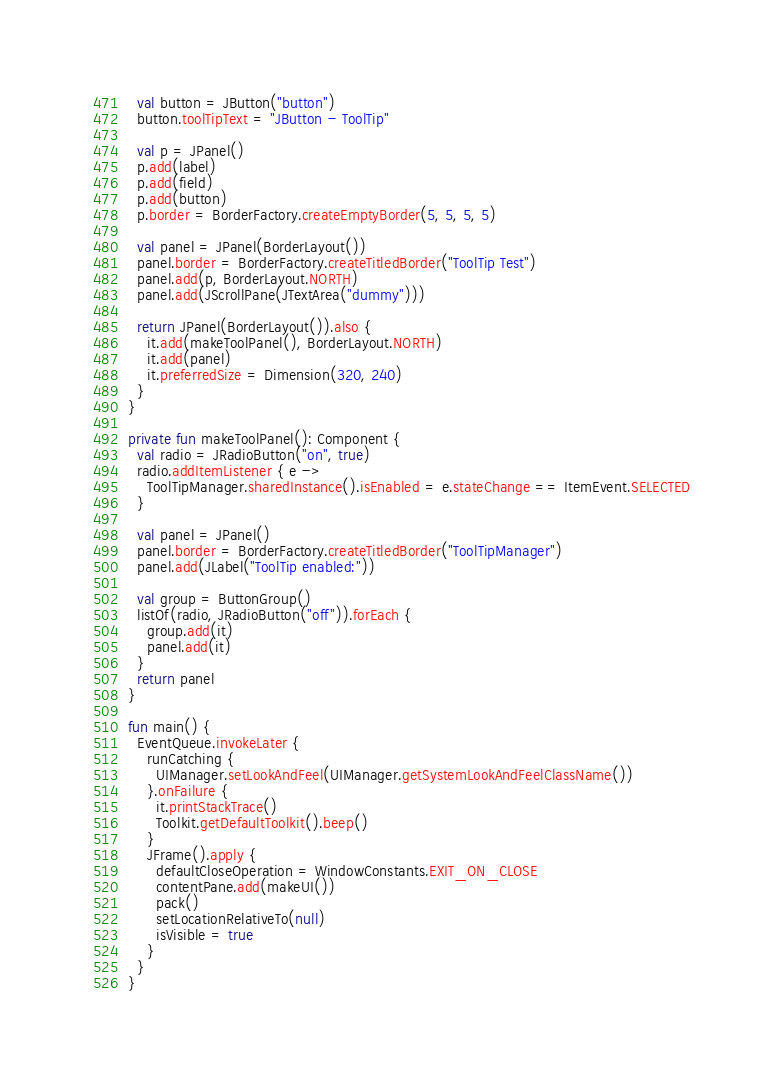<code> <loc_0><loc_0><loc_500><loc_500><_Kotlin_>  val button = JButton("button")
  button.toolTipText = "JButton - ToolTip"

  val p = JPanel()
  p.add(label)
  p.add(field)
  p.add(button)
  p.border = BorderFactory.createEmptyBorder(5, 5, 5, 5)

  val panel = JPanel(BorderLayout())
  panel.border = BorderFactory.createTitledBorder("ToolTip Test")
  panel.add(p, BorderLayout.NORTH)
  panel.add(JScrollPane(JTextArea("dummy")))

  return JPanel(BorderLayout()).also {
    it.add(makeToolPanel(), BorderLayout.NORTH)
    it.add(panel)
    it.preferredSize = Dimension(320, 240)
  }
}

private fun makeToolPanel(): Component {
  val radio = JRadioButton("on", true)
  radio.addItemListener { e ->
    ToolTipManager.sharedInstance().isEnabled = e.stateChange == ItemEvent.SELECTED
  }

  val panel = JPanel()
  panel.border = BorderFactory.createTitledBorder("ToolTipManager")
  panel.add(JLabel("ToolTip enabled:"))

  val group = ButtonGroup()
  listOf(radio, JRadioButton("off")).forEach {
    group.add(it)
    panel.add(it)
  }
  return panel
}

fun main() {
  EventQueue.invokeLater {
    runCatching {
      UIManager.setLookAndFeel(UIManager.getSystemLookAndFeelClassName())
    }.onFailure {
      it.printStackTrace()
      Toolkit.getDefaultToolkit().beep()
    }
    JFrame().apply {
      defaultCloseOperation = WindowConstants.EXIT_ON_CLOSE
      contentPane.add(makeUI())
      pack()
      setLocationRelativeTo(null)
      isVisible = true
    }
  }
}
</code> 